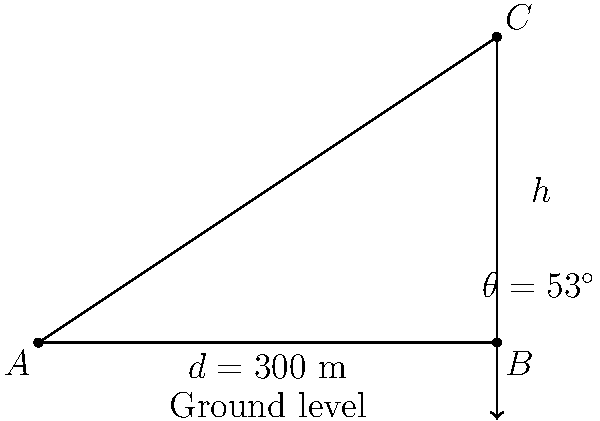During your interview with a mountaineer, you learn about a method to measure mountain heights. The mountaineer explains that from an observation point $A$, the angle of elevation to the peak $C$ is $53^\circ$. The distance from the observation point to the base of the mountain (point $B$) is 300 meters. How tall is the mountain? To solve this problem, we'll use trigonometry:

1) In the right triangle ABC, we know:
   - The angle $\theta = 53^\circ$
   - The adjacent side (distance $d$) = 300 m
   - We need to find the opposite side (height $h$)

2) The tangent of an angle in a right triangle is the ratio of the opposite side to the adjacent side:

   $\tan \theta = \frac{\text{opposite}}{\text{adjacent}} = \frac{h}{d}$

3) Rearranging this equation:

   $h = d \cdot \tan \theta$

4) Substituting the known values:

   $h = 300 \cdot \tan 53^\circ$

5) Calculate:
   $\tan 53^\circ \approx 1.3270$
   
   $h = 300 \cdot 1.3270 = 398.1$ meters

6) Round to the nearest meter:

   $h \approx 398$ meters
Answer: 398 meters 